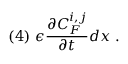Convert formula to latex. <formula><loc_0><loc_0><loc_500><loc_500>( 4 ) \ \epsilon \frac { \partial C _ { F } ^ { i , j } } { \partial t } d x \ .</formula> 